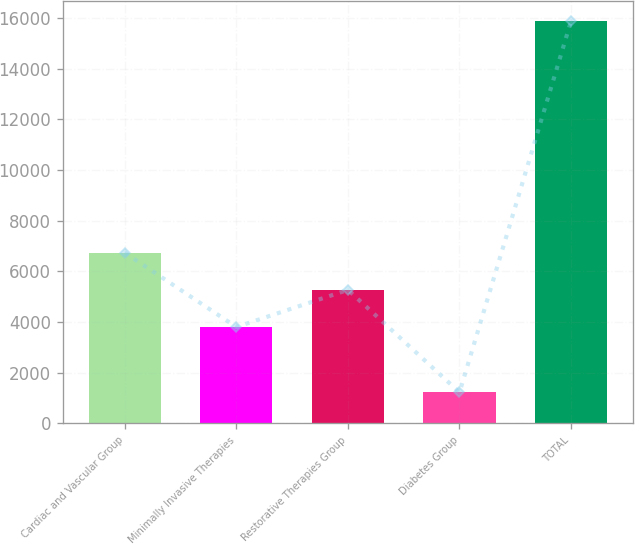Convert chart. <chart><loc_0><loc_0><loc_500><loc_500><bar_chart><fcel>Cardiac and Vascular Group<fcel>Minimally Invasive Therapies<fcel>Restorative Therapies Group<fcel>Diabetes Group<fcel>TOTAL<nl><fcel>6733.8<fcel>3804<fcel>5268.9<fcel>1226<fcel>15875<nl></chart> 